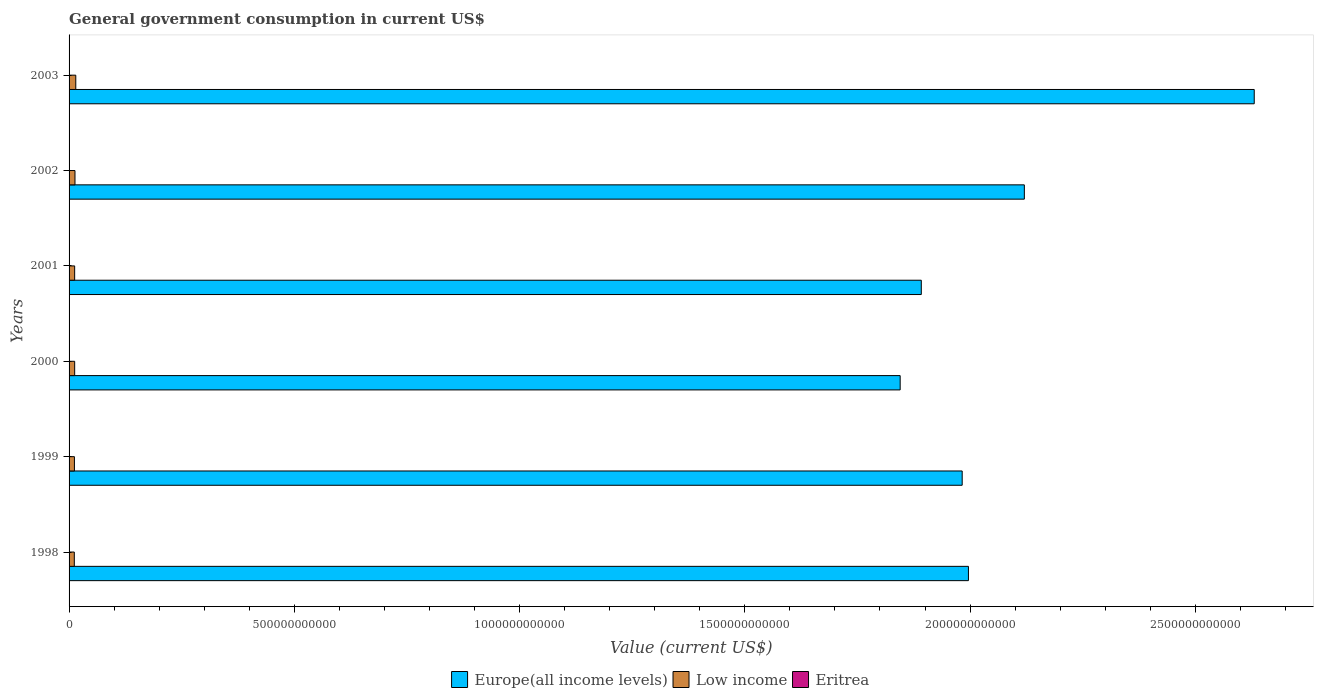How many different coloured bars are there?
Ensure brevity in your answer.  3. Are the number of bars per tick equal to the number of legend labels?
Your response must be concise. Yes. How many bars are there on the 2nd tick from the bottom?
Your answer should be compact. 3. In how many cases, is the number of bars for a given year not equal to the number of legend labels?
Your answer should be compact. 0. What is the government conusmption in Europe(all income levels) in 2000?
Provide a short and direct response. 1.84e+12. Across all years, what is the maximum government conusmption in Eritrea?
Your response must be concise. 4.79e+08. Across all years, what is the minimum government conusmption in Low income?
Your answer should be compact. 1.16e+1. In which year was the government conusmption in Europe(all income levels) minimum?
Offer a very short reply. 2000. What is the total government conusmption in Low income in the graph?
Your answer should be very brief. 7.64e+1. What is the difference between the government conusmption in Eritrea in 1998 and that in 1999?
Offer a terse response. -8.89e+07. What is the difference between the government conusmption in Eritrea in 1998 and the government conusmption in Low income in 2002?
Provide a short and direct response. -1.27e+1. What is the average government conusmption in Eritrea per year?
Ensure brevity in your answer.  3.79e+08. In the year 1999, what is the difference between the government conusmption in Europe(all income levels) and government conusmption in Low income?
Give a very brief answer. 1.97e+12. What is the ratio of the government conusmption in Low income in 2002 to that in 2003?
Your answer should be very brief. 0.88. Is the government conusmption in Low income in 1998 less than that in 2002?
Give a very brief answer. Yes. What is the difference between the highest and the second highest government conusmption in Low income?
Your answer should be compact. 1.76e+09. What is the difference between the highest and the lowest government conusmption in Eritrea?
Offer a terse response. 1.90e+08. In how many years, is the government conusmption in Low income greater than the average government conusmption in Low income taken over all years?
Your response must be concise. 2. What does the 3rd bar from the top in 2002 represents?
Offer a very short reply. Europe(all income levels). How many bars are there?
Provide a succinct answer. 18. Are all the bars in the graph horizontal?
Offer a very short reply. Yes. What is the difference between two consecutive major ticks on the X-axis?
Your answer should be compact. 5.00e+11. Are the values on the major ticks of X-axis written in scientific E-notation?
Keep it short and to the point. No. What is the title of the graph?
Your response must be concise. General government consumption in current US$. What is the label or title of the X-axis?
Provide a succinct answer. Value (current US$). What is the Value (current US$) of Europe(all income levels) in 1998?
Make the answer very short. 2.00e+12. What is the Value (current US$) of Low income in 1998?
Keep it short and to the point. 1.16e+1. What is the Value (current US$) of Eritrea in 1998?
Your response must be concise. 3.90e+08. What is the Value (current US$) in Europe(all income levels) in 1999?
Provide a succinct answer. 1.98e+12. What is the Value (current US$) in Low income in 1999?
Keep it short and to the point. 1.19e+1. What is the Value (current US$) of Eritrea in 1999?
Provide a succinct answer. 4.79e+08. What is the Value (current US$) in Europe(all income levels) in 2000?
Provide a short and direct response. 1.84e+12. What is the Value (current US$) in Low income in 2000?
Give a very brief answer. 1.24e+1. What is the Value (current US$) of Eritrea in 2000?
Provide a short and direct response. 3.87e+08. What is the Value (current US$) in Europe(all income levels) in 2001?
Keep it short and to the point. 1.89e+12. What is the Value (current US$) in Low income in 2001?
Ensure brevity in your answer.  1.24e+1. What is the Value (current US$) in Eritrea in 2001?
Ensure brevity in your answer.  3.21e+08. What is the Value (current US$) in Europe(all income levels) in 2002?
Your answer should be compact. 2.12e+12. What is the Value (current US$) in Low income in 2002?
Your answer should be very brief. 1.31e+1. What is the Value (current US$) in Eritrea in 2002?
Give a very brief answer. 2.89e+08. What is the Value (current US$) of Europe(all income levels) in 2003?
Your answer should be very brief. 2.63e+12. What is the Value (current US$) in Low income in 2003?
Ensure brevity in your answer.  1.49e+1. What is the Value (current US$) of Eritrea in 2003?
Your answer should be very brief. 4.06e+08. Across all years, what is the maximum Value (current US$) in Europe(all income levels)?
Your answer should be compact. 2.63e+12. Across all years, what is the maximum Value (current US$) of Low income?
Make the answer very short. 1.49e+1. Across all years, what is the maximum Value (current US$) in Eritrea?
Your response must be concise. 4.79e+08. Across all years, what is the minimum Value (current US$) in Europe(all income levels)?
Provide a short and direct response. 1.84e+12. Across all years, what is the minimum Value (current US$) in Low income?
Make the answer very short. 1.16e+1. Across all years, what is the minimum Value (current US$) in Eritrea?
Give a very brief answer. 2.89e+08. What is the total Value (current US$) of Europe(all income levels) in the graph?
Your answer should be compact. 1.25e+13. What is the total Value (current US$) of Low income in the graph?
Provide a succinct answer. 7.64e+1. What is the total Value (current US$) in Eritrea in the graph?
Ensure brevity in your answer.  2.27e+09. What is the difference between the Value (current US$) in Europe(all income levels) in 1998 and that in 1999?
Your answer should be very brief. 1.39e+1. What is the difference between the Value (current US$) in Low income in 1998 and that in 1999?
Offer a very short reply. -2.37e+08. What is the difference between the Value (current US$) of Eritrea in 1998 and that in 1999?
Offer a terse response. -8.89e+07. What is the difference between the Value (current US$) of Europe(all income levels) in 1998 and that in 2000?
Offer a very short reply. 1.52e+11. What is the difference between the Value (current US$) in Low income in 1998 and that in 2000?
Give a very brief answer. -7.95e+08. What is the difference between the Value (current US$) of Eritrea in 1998 and that in 2000?
Your answer should be compact. 3.08e+06. What is the difference between the Value (current US$) of Europe(all income levels) in 1998 and that in 2001?
Your answer should be very brief. 1.05e+11. What is the difference between the Value (current US$) of Low income in 1998 and that in 2001?
Your answer should be very brief. -7.64e+08. What is the difference between the Value (current US$) of Eritrea in 1998 and that in 2001?
Your answer should be compact. 6.93e+07. What is the difference between the Value (current US$) of Europe(all income levels) in 1998 and that in 2002?
Offer a very short reply. -1.24e+11. What is the difference between the Value (current US$) in Low income in 1998 and that in 2002?
Keep it short and to the point. -1.50e+09. What is the difference between the Value (current US$) in Eritrea in 1998 and that in 2002?
Provide a succinct answer. 1.01e+08. What is the difference between the Value (current US$) of Europe(all income levels) in 1998 and that in 2003?
Your response must be concise. -6.34e+11. What is the difference between the Value (current US$) in Low income in 1998 and that in 2003?
Give a very brief answer. -3.26e+09. What is the difference between the Value (current US$) of Eritrea in 1998 and that in 2003?
Your answer should be very brief. -1.54e+07. What is the difference between the Value (current US$) in Europe(all income levels) in 1999 and that in 2000?
Make the answer very short. 1.38e+11. What is the difference between the Value (current US$) in Low income in 1999 and that in 2000?
Ensure brevity in your answer.  -5.58e+08. What is the difference between the Value (current US$) in Eritrea in 1999 and that in 2000?
Give a very brief answer. 9.20e+07. What is the difference between the Value (current US$) of Europe(all income levels) in 1999 and that in 2001?
Make the answer very short. 9.08e+1. What is the difference between the Value (current US$) of Low income in 1999 and that in 2001?
Offer a very short reply. -5.27e+08. What is the difference between the Value (current US$) in Eritrea in 1999 and that in 2001?
Give a very brief answer. 1.58e+08. What is the difference between the Value (current US$) in Europe(all income levels) in 1999 and that in 2002?
Ensure brevity in your answer.  -1.38e+11. What is the difference between the Value (current US$) in Low income in 1999 and that in 2002?
Make the answer very short. -1.26e+09. What is the difference between the Value (current US$) in Eritrea in 1999 and that in 2002?
Ensure brevity in your answer.  1.90e+08. What is the difference between the Value (current US$) in Europe(all income levels) in 1999 and that in 2003?
Your answer should be compact. -6.48e+11. What is the difference between the Value (current US$) of Low income in 1999 and that in 2003?
Your answer should be very brief. -3.02e+09. What is the difference between the Value (current US$) in Eritrea in 1999 and that in 2003?
Provide a short and direct response. 7.36e+07. What is the difference between the Value (current US$) of Europe(all income levels) in 2000 and that in 2001?
Provide a succinct answer. -4.69e+1. What is the difference between the Value (current US$) of Low income in 2000 and that in 2001?
Provide a short and direct response. 3.06e+07. What is the difference between the Value (current US$) of Eritrea in 2000 and that in 2001?
Keep it short and to the point. 6.62e+07. What is the difference between the Value (current US$) of Europe(all income levels) in 2000 and that in 2002?
Offer a terse response. -2.76e+11. What is the difference between the Value (current US$) in Low income in 2000 and that in 2002?
Offer a terse response. -7.01e+08. What is the difference between the Value (current US$) of Eritrea in 2000 and that in 2002?
Your answer should be compact. 9.78e+07. What is the difference between the Value (current US$) of Europe(all income levels) in 2000 and that in 2003?
Your answer should be very brief. -7.86e+11. What is the difference between the Value (current US$) of Low income in 2000 and that in 2003?
Keep it short and to the point. -2.46e+09. What is the difference between the Value (current US$) in Eritrea in 2000 and that in 2003?
Give a very brief answer. -1.85e+07. What is the difference between the Value (current US$) in Europe(all income levels) in 2001 and that in 2002?
Offer a terse response. -2.29e+11. What is the difference between the Value (current US$) in Low income in 2001 and that in 2002?
Provide a succinct answer. -7.31e+08. What is the difference between the Value (current US$) of Eritrea in 2001 and that in 2002?
Your response must be concise. 3.17e+07. What is the difference between the Value (current US$) of Europe(all income levels) in 2001 and that in 2003?
Provide a short and direct response. -7.39e+11. What is the difference between the Value (current US$) in Low income in 2001 and that in 2003?
Provide a succinct answer. -2.49e+09. What is the difference between the Value (current US$) in Eritrea in 2001 and that in 2003?
Your response must be concise. -8.47e+07. What is the difference between the Value (current US$) of Europe(all income levels) in 2002 and that in 2003?
Make the answer very short. -5.10e+11. What is the difference between the Value (current US$) of Low income in 2002 and that in 2003?
Your response must be concise. -1.76e+09. What is the difference between the Value (current US$) of Eritrea in 2002 and that in 2003?
Your response must be concise. -1.16e+08. What is the difference between the Value (current US$) of Europe(all income levels) in 1998 and the Value (current US$) of Low income in 1999?
Provide a succinct answer. 1.98e+12. What is the difference between the Value (current US$) in Europe(all income levels) in 1998 and the Value (current US$) in Eritrea in 1999?
Your answer should be compact. 2.00e+12. What is the difference between the Value (current US$) of Low income in 1998 and the Value (current US$) of Eritrea in 1999?
Give a very brief answer. 1.12e+1. What is the difference between the Value (current US$) in Europe(all income levels) in 1998 and the Value (current US$) in Low income in 2000?
Your answer should be compact. 1.98e+12. What is the difference between the Value (current US$) of Europe(all income levels) in 1998 and the Value (current US$) of Eritrea in 2000?
Your response must be concise. 2.00e+12. What is the difference between the Value (current US$) of Low income in 1998 and the Value (current US$) of Eritrea in 2000?
Provide a short and direct response. 1.13e+1. What is the difference between the Value (current US$) in Europe(all income levels) in 1998 and the Value (current US$) in Low income in 2001?
Provide a short and direct response. 1.98e+12. What is the difference between the Value (current US$) of Europe(all income levels) in 1998 and the Value (current US$) of Eritrea in 2001?
Keep it short and to the point. 2.00e+12. What is the difference between the Value (current US$) in Low income in 1998 and the Value (current US$) in Eritrea in 2001?
Provide a succinct answer. 1.13e+1. What is the difference between the Value (current US$) in Europe(all income levels) in 1998 and the Value (current US$) in Low income in 2002?
Give a very brief answer. 1.98e+12. What is the difference between the Value (current US$) of Europe(all income levels) in 1998 and the Value (current US$) of Eritrea in 2002?
Keep it short and to the point. 2.00e+12. What is the difference between the Value (current US$) in Low income in 1998 and the Value (current US$) in Eritrea in 2002?
Give a very brief answer. 1.14e+1. What is the difference between the Value (current US$) in Europe(all income levels) in 1998 and the Value (current US$) in Low income in 2003?
Give a very brief answer. 1.98e+12. What is the difference between the Value (current US$) in Europe(all income levels) in 1998 and the Value (current US$) in Eritrea in 2003?
Your response must be concise. 2.00e+12. What is the difference between the Value (current US$) in Low income in 1998 and the Value (current US$) in Eritrea in 2003?
Provide a short and direct response. 1.12e+1. What is the difference between the Value (current US$) of Europe(all income levels) in 1999 and the Value (current US$) of Low income in 2000?
Provide a short and direct response. 1.97e+12. What is the difference between the Value (current US$) in Europe(all income levels) in 1999 and the Value (current US$) in Eritrea in 2000?
Your response must be concise. 1.98e+12. What is the difference between the Value (current US$) of Low income in 1999 and the Value (current US$) of Eritrea in 2000?
Ensure brevity in your answer.  1.15e+1. What is the difference between the Value (current US$) of Europe(all income levels) in 1999 and the Value (current US$) of Low income in 2001?
Make the answer very short. 1.97e+12. What is the difference between the Value (current US$) in Europe(all income levels) in 1999 and the Value (current US$) in Eritrea in 2001?
Ensure brevity in your answer.  1.98e+12. What is the difference between the Value (current US$) in Low income in 1999 and the Value (current US$) in Eritrea in 2001?
Your response must be concise. 1.16e+1. What is the difference between the Value (current US$) of Europe(all income levels) in 1999 and the Value (current US$) of Low income in 2002?
Provide a short and direct response. 1.97e+12. What is the difference between the Value (current US$) in Europe(all income levels) in 1999 and the Value (current US$) in Eritrea in 2002?
Ensure brevity in your answer.  1.98e+12. What is the difference between the Value (current US$) of Low income in 1999 and the Value (current US$) of Eritrea in 2002?
Make the answer very short. 1.16e+1. What is the difference between the Value (current US$) of Europe(all income levels) in 1999 and the Value (current US$) of Low income in 2003?
Offer a very short reply. 1.97e+12. What is the difference between the Value (current US$) in Europe(all income levels) in 1999 and the Value (current US$) in Eritrea in 2003?
Ensure brevity in your answer.  1.98e+12. What is the difference between the Value (current US$) in Low income in 1999 and the Value (current US$) in Eritrea in 2003?
Provide a short and direct response. 1.15e+1. What is the difference between the Value (current US$) in Europe(all income levels) in 2000 and the Value (current US$) in Low income in 2001?
Your answer should be very brief. 1.83e+12. What is the difference between the Value (current US$) in Europe(all income levels) in 2000 and the Value (current US$) in Eritrea in 2001?
Your answer should be very brief. 1.84e+12. What is the difference between the Value (current US$) of Low income in 2000 and the Value (current US$) of Eritrea in 2001?
Your answer should be very brief. 1.21e+1. What is the difference between the Value (current US$) of Europe(all income levels) in 2000 and the Value (current US$) of Low income in 2002?
Ensure brevity in your answer.  1.83e+12. What is the difference between the Value (current US$) in Europe(all income levels) in 2000 and the Value (current US$) in Eritrea in 2002?
Provide a succinct answer. 1.84e+12. What is the difference between the Value (current US$) in Low income in 2000 and the Value (current US$) in Eritrea in 2002?
Your answer should be very brief. 1.21e+1. What is the difference between the Value (current US$) in Europe(all income levels) in 2000 and the Value (current US$) in Low income in 2003?
Your answer should be very brief. 1.83e+12. What is the difference between the Value (current US$) of Europe(all income levels) in 2000 and the Value (current US$) of Eritrea in 2003?
Keep it short and to the point. 1.84e+12. What is the difference between the Value (current US$) of Low income in 2000 and the Value (current US$) of Eritrea in 2003?
Your answer should be compact. 1.20e+1. What is the difference between the Value (current US$) in Europe(all income levels) in 2001 and the Value (current US$) in Low income in 2002?
Your answer should be very brief. 1.88e+12. What is the difference between the Value (current US$) in Europe(all income levels) in 2001 and the Value (current US$) in Eritrea in 2002?
Provide a succinct answer. 1.89e+12. What is the difference between the Value (current US$) of Low income in 2001 and the Value (current US$) of Eritrea in 2002?
Your answer should be compact. 1.21e+1. What is the difference between the Value (current US$) of Europe(all income levels) in 2001 and the Value (current US$) of Low income in 2003?
Your answer should be very brief. 1.88e+12. What is the difference between the Value (current US$) of Europe(all income levels) in 2001 and the Value (current US$) of Eritrea in 2003?
Make the answer very short. 1.89e+12. What is the difference between the Value (current US$) in Low income in 2001 and the Value (current US$) in Eritrea in 2003?
Provide a succinct answer. 1.20e+1. What is the difference between the Value (current US$) in Europe(all income levels) in 2002 and the Value (current US$) in Low income in 2003?
Your answer should be very brief. 2.11e+12. What is the difference between the Value (current US$) of Europe(all income levels) in 2002 and the Value (current US$) of Eritrea in 2003?
Provide a short and direct response. 2.12e+12. What is the difference between the Value (current US$) in Low income in 2002 and the Value (current US$) in Eritrea in 2003?
Your answer should be compact. 1.27e+1. What is the average Value (current US$) in Europe(all income levels) per year?
Keep it short and to the point. 2.08e+12. What is the average Value (current US$) in Low income per year?
Your response must be concise. 1.27e+1. What is the average Value (current US$) in Eritrea per year?
Your answer should be compact. 3.79e+08. In the year 1998, what is the difference between the Value (current US$) in Europe(all income levels) and Value (current US$) in Low income?
Make the answer very short. 1.98e+12. In the year 1998, what is the difference between the Value (current US$) of Europe(all income levels) and Value (current US$) of Eritrea?
Provide a short and direct response. 2.00e+12. In the year 1998, what is the difference between the Value (current US$) of Low income and Value (current US$) of Eritrea?
Make the answer very short. 1.12e+1. In the year 1999, what is the difference between the Value (current US$) in Europe(all income levels) and Value (current US$) in Low income?
Give a very brief answer. 1.97e+12. In the year 1999, what is the difference between the Value (current US$) in Europe(all income levels) and Value (current US$) in Eritrea?
Ensure brevity in your answer.  1.98e+12. In the year 1999, what is the difference between the Value (current US$) in Low income and Value (current US$) in Eritrea?
Your answer should be compact. 1.14e+1. In the year 2000, what is the difference between the Value (current US$) of Europe(all income levels) and Value (current US$) of Low income?
Your answer should be very brief. 1.83e+12. In the year 2000, what is the difference between the Value (current US$) in Europe(all income levels) and Value (current US$) in Eritrea?
Your response must be concise. 1.84e+12. In the year 2000, what is the difference between the Value (current US$) of Low income and Value (current US$) of Eritrea?
Make the answer very short. 1.20e+1. In the year 2001, what is the difference between the Value (current US$) in Europe(all income levels) and Value (current US$) in Low income?
Provide a succinct answer. 1.88e+12. In the year 2001, what is the difference between the Value (current US$) in Europe(all income levels) and Value (current US$) in Eritrea?
Make the answer very short. 1.89e+12. In the year 2001, what is the difference between the Value (current US$) of Low income and Value (current US$) of Eritrea?
Make the answer very short. 1.21e+1. In the year 2002, what is the difference between the Value (current US$) in Europe(all income levels) and Value (current US$) in Low income?
Provide a succinct answer. 2.11e+12. In the year 2002, what is the difference between the Value (current US$) of Europe(all income levels) and Value (current US$) of Eritrea?
Your answer should be very brief. 2.12e+12. In the year 2002, what is the difference between the Value (current US$) in Low income and Value (current US$) in Eritrea?
Provide a succinct answer. 1.28e+1. In the year 2003, what is the difference between the Value (current US$) in Europe(all income levels) and Value (current US$) in Low income?
Keep it short and to the point. 2.62e+12. In the year 2003, what is the difference between the Value (current US$) of Europe(all income levels) and Value (current US$) of Eritrea?
Your response must be concise. 2.63e+12. In the year 2003, what is the difference between the Value (current US$) of Low income and Value (current US$) of Eritrea?
Make the answer very short. 1.45e+1. What is the ratio of the Value (current US$) of Europe(all income levels) in 1998 to that in 1999?
Your answer should be compact. 1.01. What is the ratio of the Value (current US$) of Low income in 1998 to that in 1999?
Provide a succinct answer. 0.98. What is the ratio of the Value (current US$) of Eritrea in 1998 to that in 1999?
Provide a short and direct response. 0.81. What is the ratio of the Value (current US$) of Europe(all income levels) in 1998 to that in 2000?
Give a very brief answer. 1.08. What is the ratio of the Value (current US$) in Low income in 1998 to that in 2000?
Make the answer very short. 0.94. What is the ratio of the Value (current US$) of Eritrea in 1998 to that in 2000?
Make the answer very short. 1.01. What is the ratio of the Value (current US$) in Europe(all income levels) in 1998 to that in 2001?
Ensure brevity in your answer.  1.06. What is the ratio of the Value (current US$) in Low income in 1998 to that in 2001?
Provide a succinct answer. 0.94. What is the ratio of the Value (current US$) of Eritrea in 1998 to that in 2001?
Give a very brief answer. 1.22. What is the ratio of the Value (current US$) of Europe(all income levels) in 1998 to that in 2002?
Your answer should be compact. 0.94. What is the ratio of the Value (current US$) of Low income in 1998 to that in 2002?
Offer a very short reply. 0.89. What is the ratio of the Value (current US$) in Eritrea in 1998 to that in 2002?
Keep it short and to the point. 1.35. What is the ratio of the Value (current US$) of Europe(all income levels) in 1998 to that in 2003?
Provide a short and direct response. 0.76. What is the ratio of the Value (current US$) of Low income in 1998 to that in 2003?
Ensure brevity in your answer.  0.78. What is the ratio of the Value (current US$) of Eritrea in 1998 to that in 2003?
Keep it short and to the point. 0.96. What is the ratio of the Value (current US$) of Europe(all income levels) in 1999 to that in 2000?
Provide a short and direct response. 1.07. What is the ratio of the Value (current US$) of Low income in 1999 to that in 2000?
Your answer should be very brief. 0.96. What is the ratio of the Value (current US$) of Eritrea in 1999 to that in 2000?
Ensure brevity in your answer.  1.24. What is the ratio of the Value (current US$) of Europe(all income levels) in 1999 to that in 2001?
Your answer should be compact. 1.05. What is the ratio of the Value (current US$) in Low income in 1999 to that in 2001?
Offer a terse response. 0.96. What is the ratio of the Value (current US$) in Eritrea in 1999 to that in 2001?
Offer a very short reply. 1.49. What is the ratio of the Value (current US$) of Europe(all income levels) in 1999 to that in 2002?
Provide a succinct answer. 0.93. What is the ratio of the Value (current US$) in Low income in 1999 to that in 2002?
Your answer should be very brief. 0.9. What is the ratio of the Value (current US$) in Eritrea in 1999 to that in 2002?
Your answer should be very brief. 1.66. What is the ratio of the Value (current US$) in Europe(all income levels) in 1999 to that in 2003?
Make the answer very short. 0.75. What is the ratio of the Value (current US$) of Low income in 1999 to that in 2003?
Your answer should be compact. 0.8. What is the ratio of the Value (current US$) of Eritrea in 1999 to that in 2003?
Your answer should be very brief. 1.18. What is the ratio of the Value (current US$) in Europe(all income levels) in 2000 to that in 2001?
Keep it short and to the point. 0.98. What is the ratio of the Value (current US$) of Low income in 2000 to that in 2001?
Provide a succinct answer. 1. What is the ratio of the Value (current US$) of Eritrea in 2000 to that in 2001?
Ensure brevity in your answer.  1.21. What is the ratio of the Value (current US$) of Europe(all income levels) in 2000 to that in 2002?
Offer a very short reply. 0.87. What is the ratio of the Value (current US$) of Low income in 2000 to that in 2002?
Provide a succinct answer. 0.95. What is the ratio of the Value (current US$) of Eritrea in 2000 to that in 2002?
Your response must be concise. 1.34. What is the ratio of the Value (current US$) of Europe(all income levels) in 2000 to that in 2003?
Provide a short and direct response. 0.7. What is the ratio of the Value (current US$) of Low income in 2000 to that in 2003?
Provide a succinct answer. 0.83. What is the ratio of the Value (current US$) in Eritrea in 2000 to that in 2003?
Provide a short and direct response. 0.95. What is the ratio of the Value (current US$) of Europe(all income levels) in 2001 to that in 2002?
Offer a terse response. 0.89. What is the ratio of the Value (current US$) in Low income in 2001 to that in 2002?
Give a very brief answer. 0.94. What is the ratio of the Value (current US$) in Eritrea in 2001 to that in 2002?
Provide a succinct answer. 1.11. What is the ratio of the Value (current US$) in Europe(all income levels) in 2001 to that in 2003?
Your answer should be very brief. 0.72. What is the ratio of the Value (current US$) in Low income in 2001 to that in 2003?
Your response must be concise. 0.83. What is the ratio of the Value (current US$) in Eritrea in 2001 to that in 2003?
Ensure brevity in your answer.  0.79. What is the ratio of the Value (current US$) in Europe(all income levels) in 2002 to that in 2003?
Offer a terse response. 0.81. What is the ratio of the Value (current US$) in Low income in 2002 to that in 2003?
Offer a terse response. 0.88. What is the ratio of the Value (current US$) in Eritrea in 2002 to that in 2003?
Keep it short and to the point. 0.71. What is the difference between the highest and the second highest Value (current US$) in Europe(all income levels)?
Provide a succinct answer. 5.10e+11. What is the difference between the highest and the second highest Value (current US$) of Low income?
Offer a terse response. 1.76e+09. What is the difference between the highest and the second highest Value (current US$) of Eritrea?
Your answer should be compact. 7.36e+07. What is the difference between the highest and the lowest Value (current US$) of Europe(all income levels)?
Your response must be concise. 7.86e+11. What is the difference between the highest and the lowest Value (current US$) of Low income?
Keep it short and to the point. 3.26e+09. What is the difference between the highest and the lowest Value (current US$) of Eritrea?
Keep it short and to the point. 1.90e+08. 